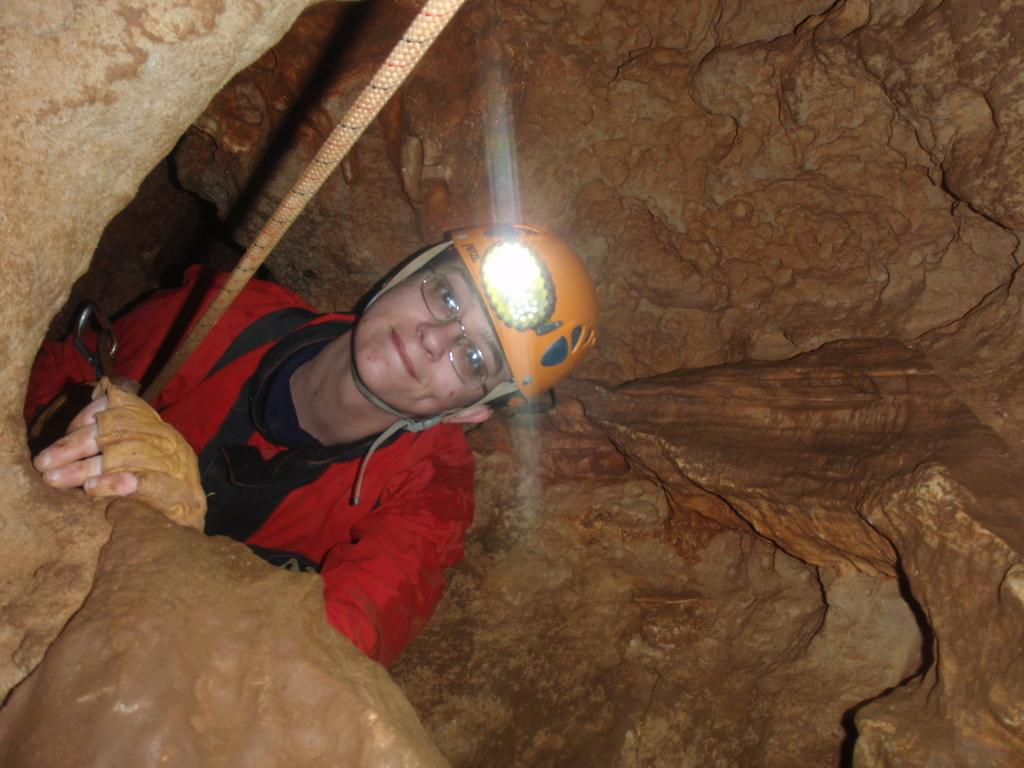Who is present in the image? There is a woman in the image. What is the woman doing in the image? The woman is smiling in the image. Where is the woman located in the image? The woman is in a cave in the image. What type of dock can be seen in the image? There is no dock present in the image; it features a woman in a cave. What kind of peace symbol is visible in the image? There is no peace symbol present in the image; it features a woman in a cave. 